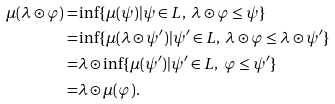Convert formula to latex. <formula><loc_0><loc_0><loc_500><loc_500>\mu ( \lambda \odot \varphi ) = & \inf \{ \mu ( \psi ) | \psi \in L , \ \lambda \odot \varphi \leq \psi \} \\ = & \inf \{ \mu ( \lambda \odot \psi ^ { \prime } ) | \psi ^ { \prime } \in L , \ \lambda \odot \varphi \leq \lambda \odot \psi ^ { \prime } \} \\ = & \lambda \odot \inf \{ \mu ( \psi ^ { \prime } ) | \psi ^ { \prime } \in L , \ \varphi \leq \psi ^ { \prime } \} \\ = & \lambda \odot \mu ( \varphi ) .</formula> 